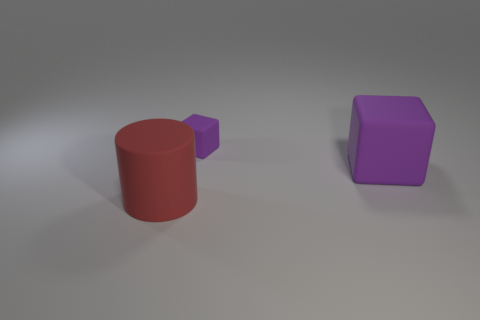Add 1 tiny purple shiny cylinders. How many objects exist? 4 Subtract all cubes. How many objects are left? 1 Add 2 purple rubber blocks. How many purple rubber blocks are left? 4 Add 1 matte cylinders. How many matte cylinders exist? 2 Subtract 0 blue cylinders. How many objects are left? 3 Subtract all green cylinders. Subtract all yellow blocks. How many cylinders are left? 1 Subtract all large cyan metal blocks. Subtract all red cylinders. How many objects are left? 2 